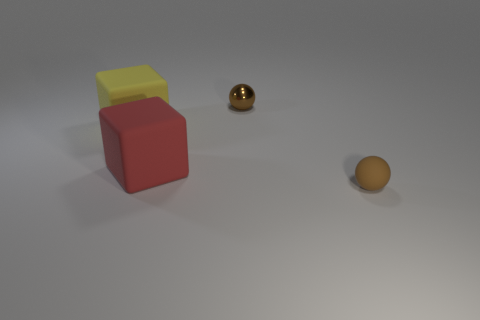Can you tell me what the red object is made of? The red object looks like it could be a simple geometric solid, possibly made of a matte material such as plastic or wood, given its opaque appearance and lack of reflective qualities. 